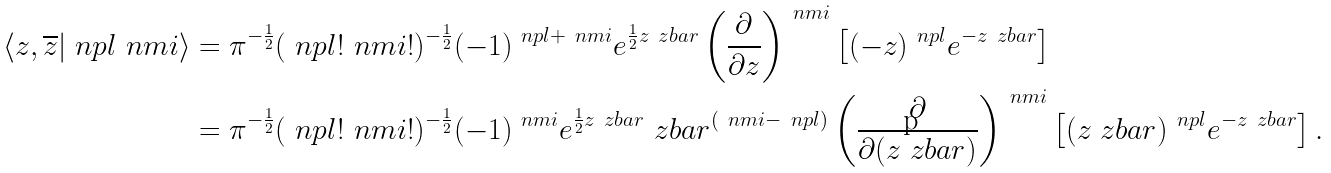<formula> <loc_0><loc_0><loc_500><loc_500>\langle z , \overline { z } | \ n p l \ n m i \rangle & = \pi ^ { - \frac { 1 } { 2 } } ( \ n p l ! \ n m i ! ) ^ { - \frac { 1 } { 2 } } ( - 1 ) ^ { \ n p l + \ n m i } e ^ { \frac { 1 } { 2 } z \ z b a r } \left ( \frac { \partial } { \partial z } \right ) ^ { \ n m i } \left [ ( - z ) ^ { \ n p l } e ^ { - z \ z b a r } \right ] \\ & = \pi ^ { - \frac { 1 } { 2 } } ( \ n p l ! \ n m i ! ) ^ { - \frac { 1 } { 2 } } ( - 1 ) ^ { \ n m i } e ^ { \frac { 1 } { 2 } z \ z b a r } \ z b a r ^ { ( \ n m i - \ n p l ) } \left ( \frac { \partial } { \partial ( z \ z b a r ) } \right ) ^ { \ n m i } \left [ ( z \ z b a r ) ^ { \ n p l } e ^ { - z \ z b a r } \right ] .</formula> 